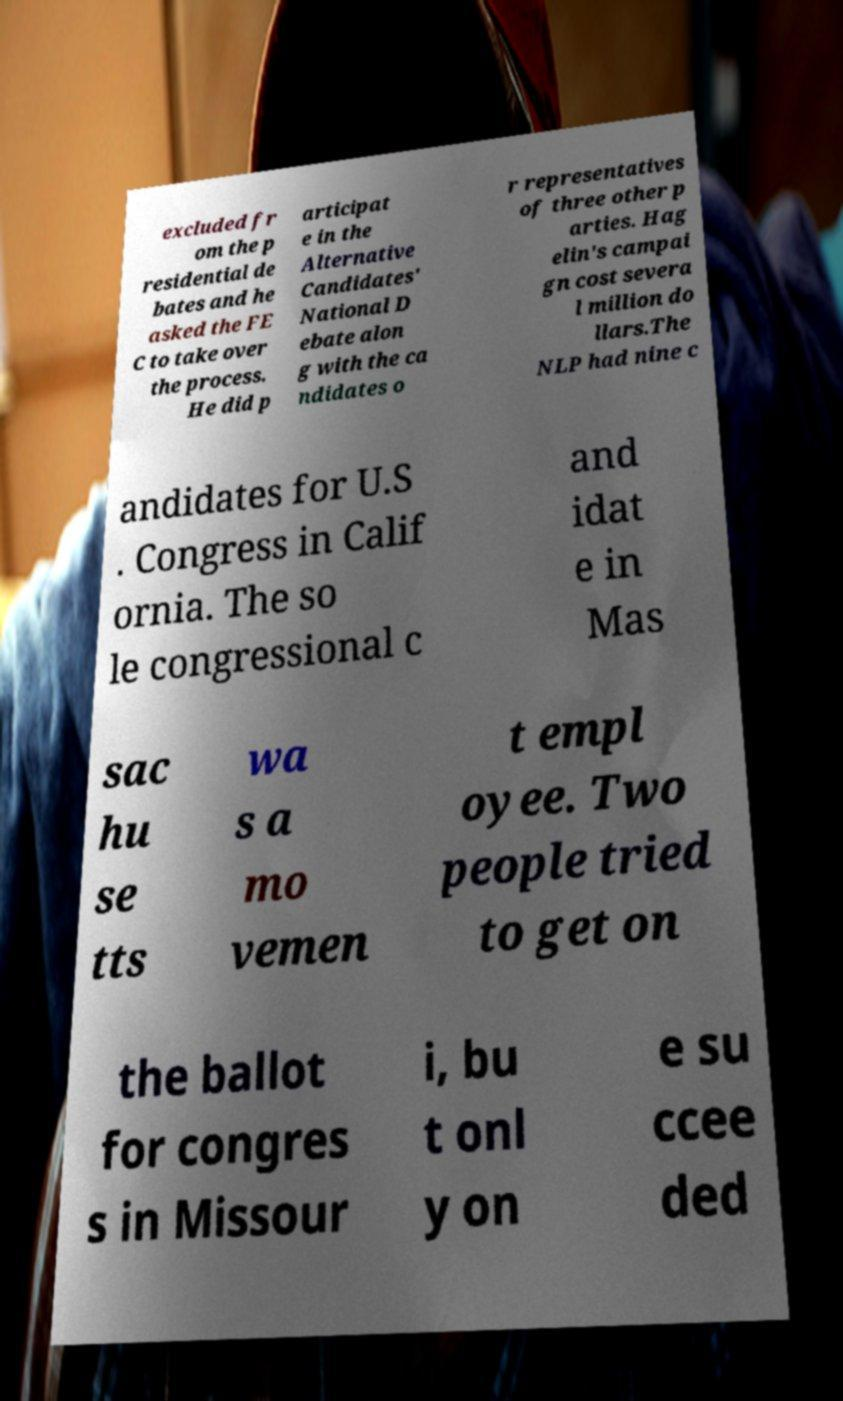I need the written content from this picture converted into text. Can you do that? excluded fr om the p residential de bates and he asked the FE C to take over the process. He did p articipat e in the Alternative Candidates' National D ebate alon g with the ca ndidates o r representatives of three other p arties. Hag elin's campai gn cost severa l million do llars.The NLP had nine c andidates for U.S . Congress in Calif ornia. The so le congressional c and idat e in Mas sac hu se tts wa s a mo vemen t empl oyee. Two people tried to get on the ballot for congres s in Missour i, bu t onl y on e su ccee ded 